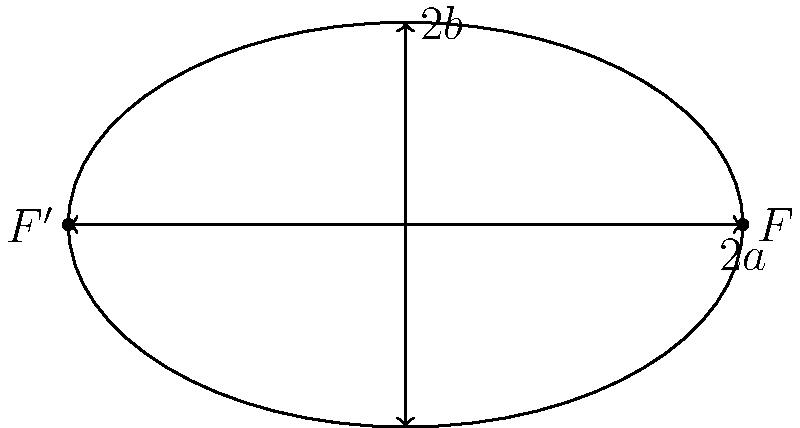In the ellipse shown above, the length of the major axis is $10$ units and the length of the minor axis is $6$ units. Determine the eccentricity of this ellipse. Let's approach this step-by-step:

1) The eccentricity of an ellipse is given by the formula:

   $$e = \sqrt{1 - \frac{b^2}{a^2}}$$

   where $a$ is half the length of the major axis and $b$ is half the length of the minor axis.

2) From the given information:
   Major axis length = $10$ units, so $a = 5$ units
   Minor axis length = $6$ units, so $b = 3$ units

3) Let's substitute these values into our formula:

   $$e = \sqrt{1 - \frac{3^2}{5^2}}$$

4) Simplify inside the parentheses:

   $$e = \sqrt{1 - \frac{9}{25}}$$

5) Subtract:

   $$e = \sqrt{\frac{16}{25}}$$

6) Simplify the fraction under the square root:

   $$e = \frac{4}{5}$$

Therefore, the eccentricity of this ellipse is $\frac{4}{5}$ or $0.8$.
Answer: $\frac{4}{5}$ or $0.8$ 